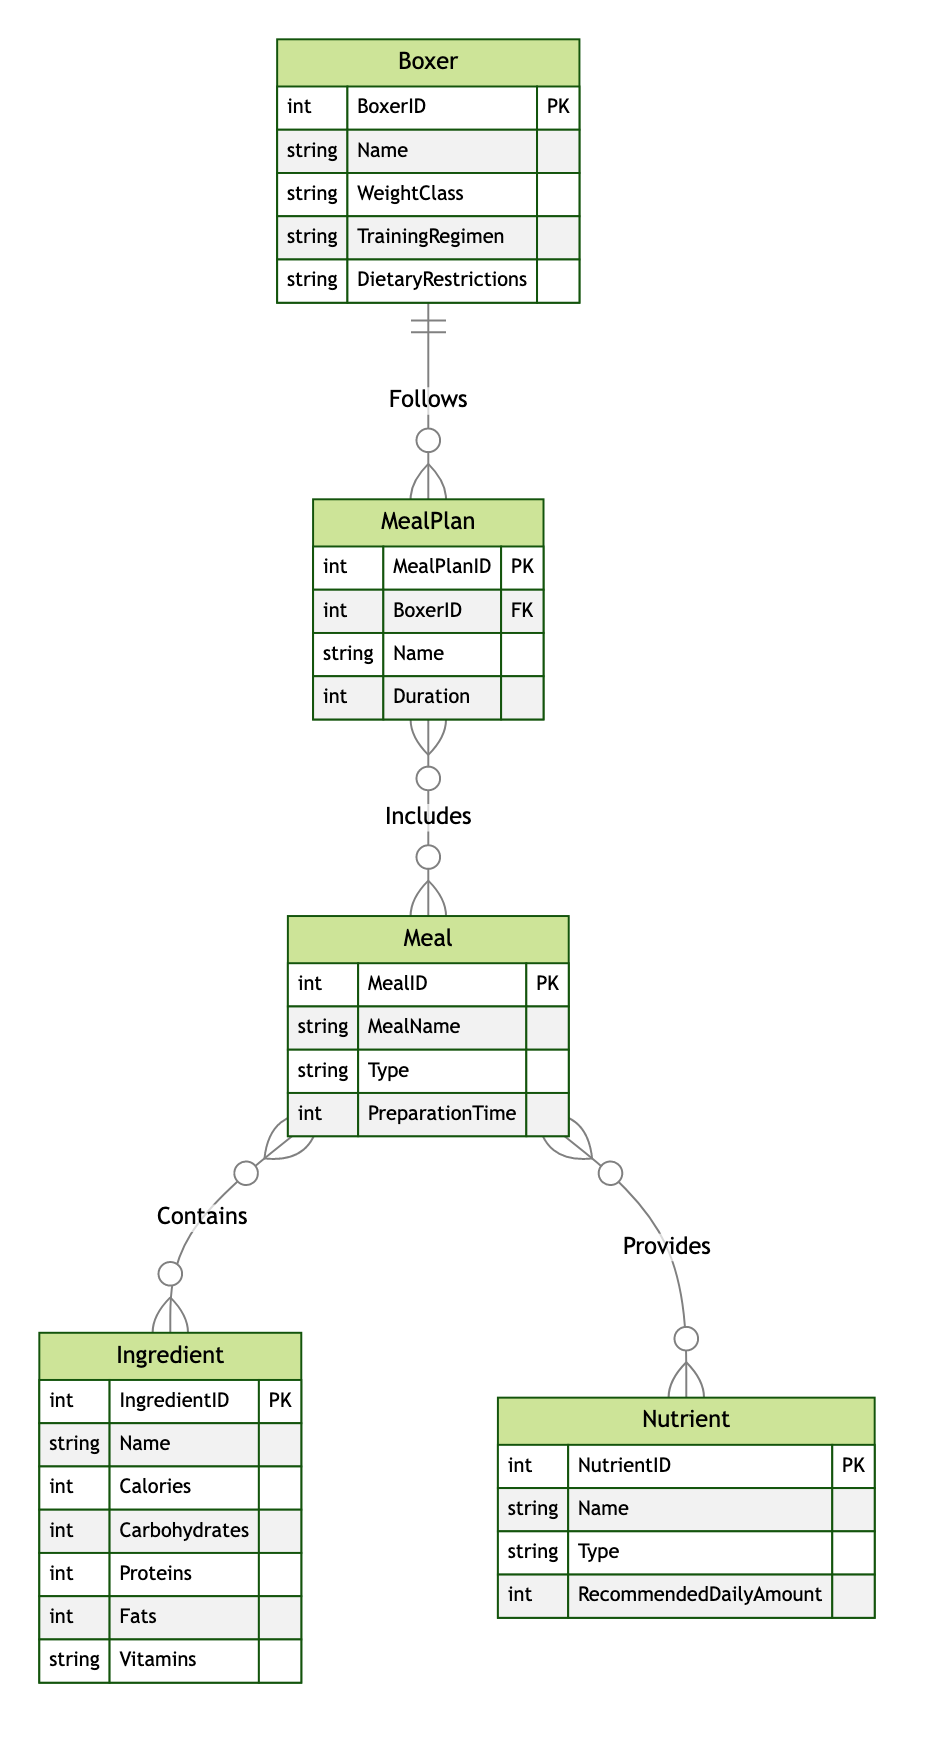What is the primary key of the Meal entity? The primary key for the Meal entity is identified as MealID in the diagram, which uniquely identifies each meal entry.
Answer: MealID How many relationships does the Boxer entity have? In the diagram, the Boxer entity is connected to the MealPlan entity through the "Follows" relationship. Therefore, Boxer has one relationship.
Answer: One What type of relationship exists between Meal and Nutrient? The diagram shows that the Meal and Nutrient entities are connected through the "Provides" relationship, indicating a many-to-many relationship.
Answer: Many-to-Many What is the recommended daily amount of nutrients associated with a specific NutrientID? The diagram indicates that the Nutrient entity includes an attribute called RecommendedDailyAmount, which specifies the values for various nutrients; however, a specific NutrientID was not provided in the question.
Answer: RecommendedDailyAmount How many different entities are represented in the diagram? The diagram contains five entities: Boxer, Meal, Nutrient, Ingredient, and MealPlan, tallying a total of five distinct entities.
Answer: Five What is the cardinality between MealPlan and Meal? The relationship between MealPlan and Meal is described as Many-to-Many in the diagram, meaning a meal plan can include multiple meals and a meal can be part of multiple meal plans.
Answer: Many-to-Many Which entity contains the attribute "TrainingRegimen"? The TrainingRegimen attribute is part of the Boxer entity, which helps to categorize the boxer's training schedule and regimen.
Answer: Boxer What is the purpose of the Contains relationship in this diagram? The Contains relationship connects Meal and Ingredient, signifying that meals can be composed of multiple ingredients and that ingredients can belong to multiple meals.
Answer: Composition of ingredients What does the Foreign Key in the MealPlan entity reference? The Foreign Key in the MealPlan entity, labeled BoxerID, references the Boxer entity's primary key, establishing a link between the meal plan and the specific boxer it is designed for.
Answer: BoxerID 